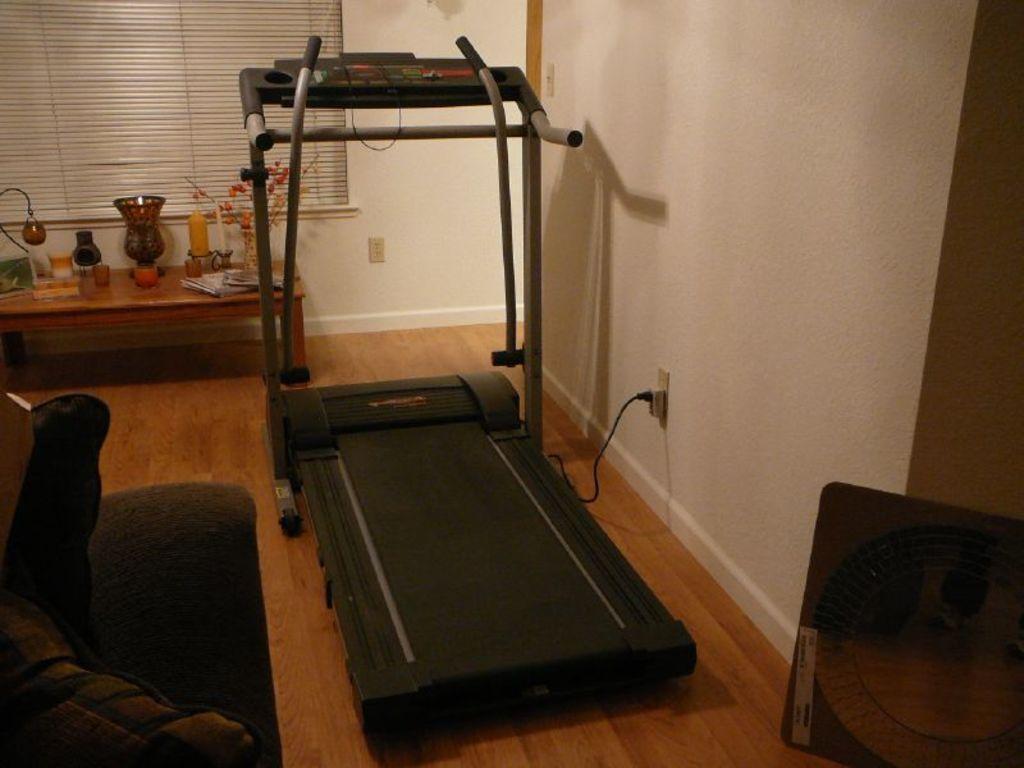Please provide a concise description of this image. In the picture I can see a sofa which has few objects placed on it in the left corner and there is a treadmill beside it and there is an object and a white color wall in the right corner and there is a table which has few objects placed on it in the background. 